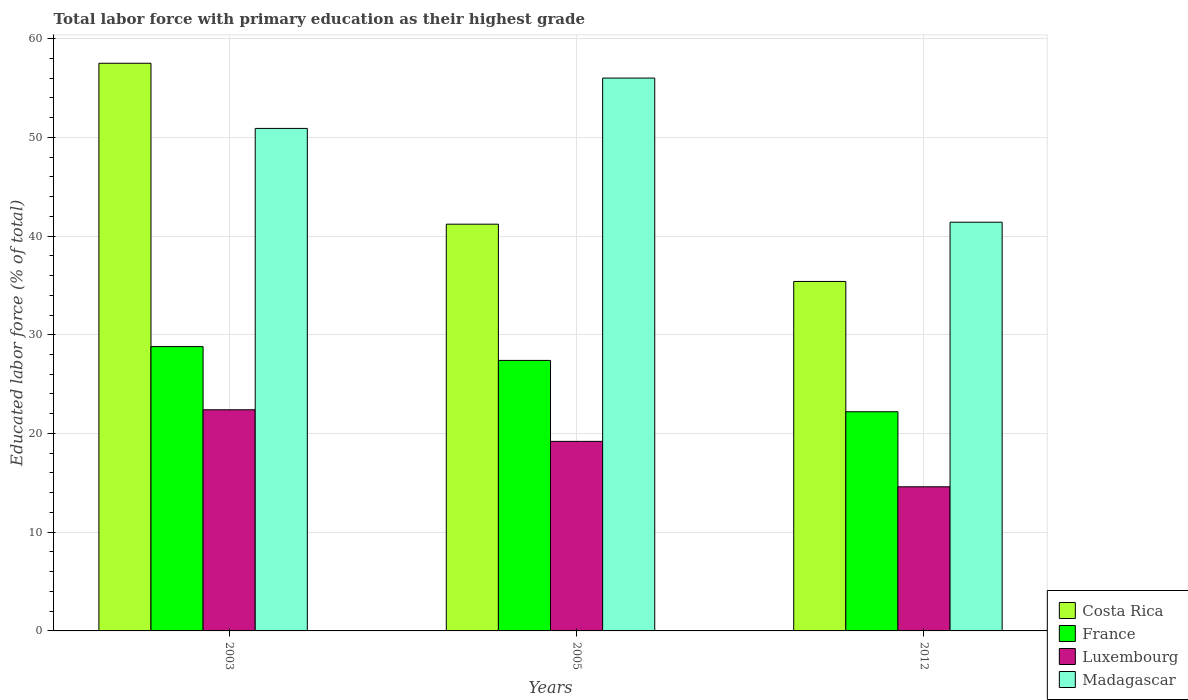How many groups of bars are there?
Your answer should be very brief. 3. How many bars are there on the 1st tick from the left?
Your answer should be compact. 4. How many bars are there on the 3rd tick from the right?
Provide a short and direct response. 4. In how many cases, is the number of bars for a given year not equal to the number of legend labels?
Ensure brevity in your answer.  0. What is the percentage of total labor force with primary education in France in 2005?
Provide a succinct answer. 27.4. Across all years, what is the maximum percentage of total labor force with primary education in France?
Provide a succinct answer. 28.8. Across all years, what is the minimum percentage of total labor force with primary education in France?
Provide a succinct answer. 22.2. In which year was the percentage of total labor force with primary education in Costa Rica minimum?
Offer a terse response. 2012. What is the total percentage of total labor force with primary education in Madagascar in the graph?
Give a very brief answer. 148.3. What is the difference between the percentage of total labor force with primary education in France in 2005 and that in 2012?
Ensure brevity in your answer.  5.2. What is the difference between the percentage of total labor force with primary education in Costa Rica in 2005 and the percentage of total labor force with primary education in Madagascar in 2012?
Give a very brief answer. -0.2. What is the average percentage of total labor force with primary education in Madagascar per year?
Provide a short and direct response. 49.43. In the year 2005, what is the difference between the percentage of total labor force with primary education in Costa Rica and percentage of total labor force with primary education in Luxembourg?
Your response must be concise. 22. In how many years, is the percentage of total labor force with primary education in France greater than 30 %?
Ensure brevity in your answer.  0. What is the ratio of the percentage of total labor force with primary education in Luxembourg in 2003 to that in 2005?
Ensure brevity in your answer.  1.17. What is the difference between the highest and the second highest percentage of total labor force with primary education in Madagascar?
Keep it short and to the point. 5.1. What is the difference between the highest and the lowest percentage of total labor force with primary education in France?
Offer a terse response. 6.6. In how many years, is the percentage of total labor force with primary education in France greater than the average percentage of total labor force with primary education in France taken over all years?
Provide a succinct answer. 2. Is the sum of the percentage of total labor force with primary education in Madagascar in 2003 and 2005 greater than the maximum percentage of total labor force with primary education in France across all years?
Offer a very short reply. Yes. Is it the case that in every year, the sum of the percentage of total labor force with primary education in Madagascar and percentage of total labor force with primary education in France is greater than the sum of percentage of total labor force with primary education in Costa Rica and percentage of total labor force with primary education in Luxembourg?
Your answer should be compact. Yes. What does the 3rd bar from the left in 2012 represents?
Give a very brief answer. Luxembourg. What does the 2nd bar from the right in 2012 represents?
Your response must be concise. Luxembourg. How many bars are there?
Provide a short and direct response. 12. Are all the bars in the graph horizontal?
Offer a very short reply. No. How many years are there in the graph?
Provide a short and direct response. 3. What is the difference between two consecutive major ticks on the Y-axis?
Your answer should be very brief. 10. Are the values on the major ticks of Y-axis written in scientific E-notation?
Give a very brief answer. No. Does the graph contain grids?
Offer a very short reply. Yes. How many legend labels are there?
Provide a short and direct response. 4. How are the legend labels stacked?
Your answer should be compact. Vertical. What is the title of the graph?
Provide a short and direct response. Total labor force with primary education as their highest grade. What is the label or title of the X-axis?
Make the answer very short. Years. What is the label or title of the Y-axis?
Your answer should be very brief. Educated labor force (% of total). What is the Educated labor force (% of total) of Costa Rica in 2003?
Keep it short and to the point. 57.5. What is the Educated labor force (% of total) of France in 2003?
Your answer should be very brief. 28.8. What is the Educated labor force (% of total) of Luxembourg in 2003?
Your response must be concise. 22.4. What is the Educated labor force (% of total) of Madagascar in 2003?
Your response must be concise. 50.9. What is the Educated labor force (% of total) of Costa Rica in 2005?
Make the answer very short. 41.2. What is the Educated labor force (% of total) of France in 2005?
Give a very brief answer. 27.4. What is the Educated labor force (% of total) in Luxembourg in 2005?
Your answer should be compact. 19.2. What is the Educated labor force (% of total) in Costa Rica in 2012?
Offer a very short reply. 35.4. What is the Educated labor force (% of total) in France in 2012?
Offer a very short reply. 22.2. What is the Educated labor force (% of total) in Luxembourg in 2012?
Keep it short and to the point. 14.6. What is the Educated labor force (% of total) in Madagascar in 2012?
Your answer should be compact. 41.4. Across all years, what is the maximum Educated labor force (% of total) in Costa Rica?
Your answer should be compact. 57.5. Across all years, what is the maximum Educated labor force (% of total) of France?
Offer a terse response. 28.8. Across all years, what is the maximum Educated labor force (% of total) in Luxembourg?
Provide a succinct answer. 22.4. Across all years, what is the maximum Educated labor force (% of total) in Madagascar?
Offer a terse response. 56. Across all years, what is the minimum Educated labor force (% of total) of Costa Rica?
Provide a succinct answer. 35.4. Across all years, what is the minimum Educated labor force (% of total) in France?
Your response must be concise. 22.2. Across all years, what is the minimum Educated labor force (% of total) in Luxembourg?
Provide a short and direct response. 14.6. Across all years, what is the minimum Educated labor force (% of total) in Madagascar?
Offer a terse response. 41.4. What is the total Educated labor force (% of total) of Costa Rica in the graph?
Offer a very short reply. 134.1. What is the total Educated labor force (% of total) in France in the graph?
Give a very brief answer. 78.4. What is the total Educated labor force (% of total) of Luxembourg in the graph?
Offer a terse response. 56.2. What is the total Educated labor force (% of total) in Madagascar in the graph?
Make the answer very short. 148.3. What is the difference between the Educated labor force (% of total) in Luxembourg in 2003 and that in 2005?
Your response must be concise. 3.2. What is the difference between the Educated labor force (% of total) in Madagascar in 2003 and that in 2005?
Your answer should be very brief. -5.1. What is the difference between the Educated labor force (% of total) of Costa Rica in 2003 and that in 2012?
Provide a succinct answer. 22.1. What is the difference between the Educated labor force (% of total) in France in 2003 and that in 2012?
Your response must be concise. 6.6. What is the difference between the Educated labor force (% of total) in Costa Rica in 2005 and that in 2012?
Give a very brief answer. 5.8. What is the difference between the Educated labor force (% of total) of France in 2005 and that in 2012?
Provide a short and direct response. 5.2. What is the difference between the Educated labor force (% of total) in Costa Rica in 2003 and the Educated labor force (% of total) in France in 2005?
Offer a terse response. 30.1. What is the difference between the Educated labor force (% of total) of Costa Rica in 2003 and the Educated labor force (% of total) of Luxembourg in 2005?
Your response must be concise. 38.3. What is the difference between the Educated labor force (% of total) in France in 2003 and the Educated labor force (% of total) in Luxembourg in 2005?
Keep it short and to the point. 9.6. What is the difference between the Educated labor force (% of total) in France in 2003 and the Educated labor force (% of total) in Madagascar in 2005?
Make the answer very short. -27.2. What is the difference between the Educated labor force (% of total) in Luxembourg in 2003 and the Educated labor force (% of total) in Madagascar in 2005?
Ensure brevity in your answer.  -33.6. What is the difference between the Educated labor force (% of total) in Costa Rica in 2003 and the Educated labor force (% of total) in France in 2012?
Make the answer very short. 35.3. What is the difference between the Educated labor force (% of total) of Costa Rica in 2003 and the Educated labor force (% of total) of Luxembourg in 2012?
Give a very brief answer. 42.9. What is the difference between the Educated labor force (% of total) in Luxembourg in 2003 and the Educated labor force (% of total) in Madagascar in 2012?
Provide a short and direct response. -19. What is the difference between the Educated labor force (% of total) of Costa Rica in 2005 and the Educated labor force (% of total) of France in 2012?
Ensure brevity in your answer.  19. What is the difference between the Educated labor force (% of total) in Costa Rica in 2005 and the Educated labor force (% of total) in Luxembourg in 2012?
Make the answer very short. 26.6. What is the difference between the Educated labor force (% of total) in Costa Rica in 2005 and the Educated labor force (% of total) in Madagascar in 2012?
Make the answer very short. -0.2. What is the difference between the Educated labor force (% of total) of Luxembourg in 2005 and the Educated labor force (% of total) of Madagascar in 2012?
Your answer should be compact. -22.2. What is the average Educated labor force (% of total) in Costa Rica per year?
Give a very brief answer. 44.7. What is the average Educated labor force (% of total) in France per year?
Provide a short and direct response. 26.13. What is the average Educated labor force (% of total) of Luxembourg per year?
Your answer should be compact. 18.73. What is the average Educated labor force (% of total) in Madagascar per year?
Your response must be concise. 49.43. In the year 2003, what is the difference between the Educated labor force (% of total) in Costa Rica and Educated labor force (% of total) in France?
Offer a terse response. 28.7. In the year 2003, what is the difference between the Educated labor force (% of total) in Costa Rica and Educated labor force (% of total) in Luxembourg?
Your answer should be compact. 35.1. In the year 2003, what is the difference between the Educated labor force (% of total) of France and Educated labor force (% of total) of Luxembourg?
Make the answer very short. 6.4. In the year 2003, what is the difference between the Educated labor force (% of total) in France and Educated labor force (% of total) in Madagascar?
Keep it short and to the point. -22.1. In the year 2003, what is the difference between the Educated labor force (% of total) in Luxembourg and Educated labor force (% of total) in Madagascar?
Offer a terse response. -28.5. In the year 2005, what is the difference between the Educated labor force (% of total) in Costa Rica and Educated labor force (% of total) in Luxembourg?
Offer a terse response. 22. In the year 2005, what is the difference between the Educated labor force (% of total) of Costa Rica and Educated labor force (% of total) of Madagascar?
Your answer should be very brief. -14.8. In the year 2005, what is the difference between the Educated labor force (% of total) in France and Educated labor force (% of total) in Luxembourg?
Your answer should be compact. 8.2. In the year 2005, what is the difference between the Educated labor force (% of total) in France and Educated labor force (% of total) in Madagascar?
Ensure brevity in your answer.  -28.6. In the year 2005, what is the difference between the Educated labor force (% of total) of Luxembourg and Educated labor force (% of total) of Madagascar?
Make the answer very short. -36.8. In the year 2012, what is the difference between the Educated labor force (% of total) of Costa Rica and Educated labor force (% of total) of Luxembourg?
Ensure brevity in your answer.  20.8. In the year 2012, what is the difference between the Educated labor force (% of total) of France and Educated labor force (% of total) of Madagascar?
Your answer should be compact. -19.2. In the year 2012, what is the difference between the Educated labor force (% of total) of Luxembourg and Educated labor force (% of total) of Madagascar?
Your answer should be very brief. -26.8. What is the ratio of the Educated labor force (% of total) of Costa Rica in 2003 to that in 2005?
Give a very brief answer. 1.4. What is the ratio of the Educated labor force (% of total) in France in 2003 to that in 2005?
Your answer should be compact. 1.05. What is the ratio of the Educated labor force (% of total) of Luxembourg in 2003 to that in 2005?
Keep it short and to the point. 1.17. What is the ratio of the Educated labor force (% of total) in Madagascar in 2003 to that in 2005?
Offer a very short reply. 0.91. What is the ratio of the Educated labor force (% of total) of Costa Rica in 2003 to that in 2012?
Your response must be concise. 1.62. What is the ratio of the Educated labor force (% of total) of France in 2003 to that in 2012?
Ensure brevity in your answer.  1.3. What is the ratio of the Educated labor force (% of total) of Luxembourg in 2003 to that in 2012?
Keep it short and to the point. 1.53. What is the ratio of the Educated labor force (% of total) in Madagascar in 2003 to that in 2012?
Offer a very short reply. 1.23. What is the ratio of the Educated labor force (% of total) in Costa Rica in 2005 to that in 2012?
Your answer should be compact. 1.16. What is the ratio of the Educated labor force (% of total) of France in 2005 to that in 2012?
Make the answer very short. 1.23. What is the ratio of the Educated labor force (% of total) in Luxembourg in 2005 to that in 2012?
Provide a succinct answer. 1.32. What is the ratio of the Educated labor force (% of total) of Madagascar in 2005 to that in 2012?
Ensure brevity in your answer.  1.35. What is the difference between the highest and the second highest Educated labor force (% of total) of Madagascar?
Make the answer very short. 5.1. What is the difference between the highest and the lowest Educated labor force (% of total) of Costa Rica?
Your answer should be compact. 22.1. What is the difference between the highest and the lowest Educated labor force (% of total) in Luxembourg?
Your response must be concise. 7.8. What is the difference between the highest and the lowest Educated labor force (% of total) in Madagascar?
Provide a succinct answer. 14.6. 